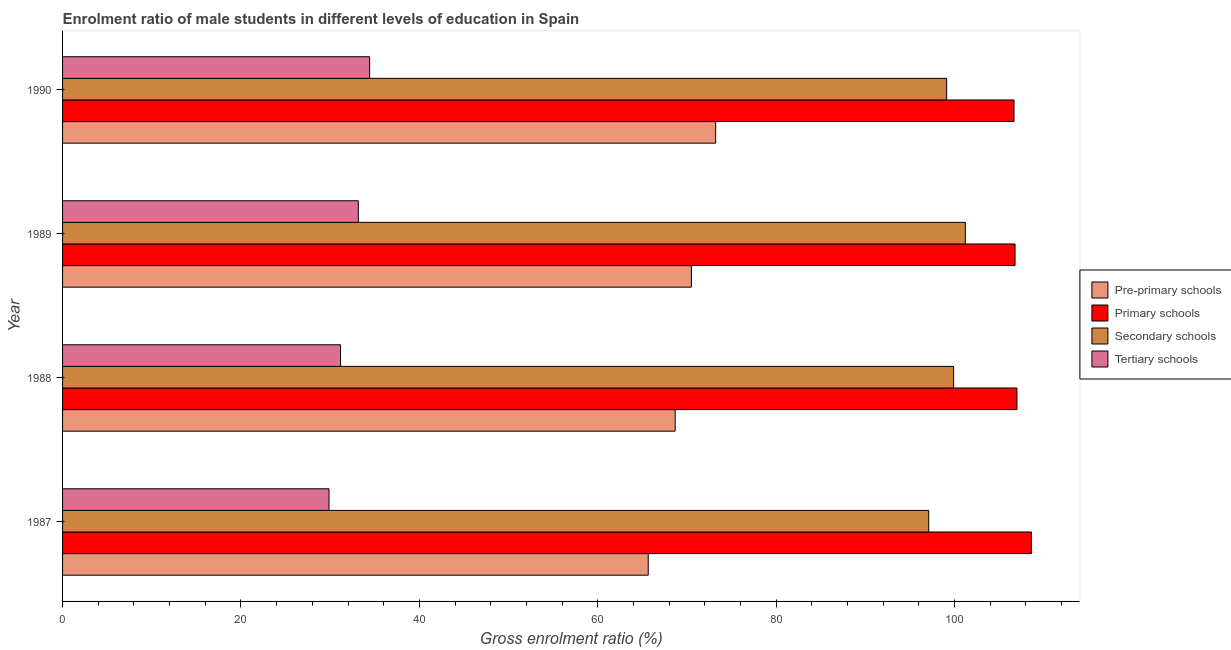How many groups of bars are there?
Keep it short and to the point. 4. Are the number of bars per tick equal to the number of legend labels?
Your answer should be compact. Yes. How many bars are there on the 3rd tick from the bottom?
Make the answer very short. 4. What is the gross enrolment ratio(female) in primary schools in 1989?
Provide a succinct answer. 106.78. Across all years, what is the maximum gross enrolment ratio(female) in pre-primary schools?
Offer a terse response. 73.22. Across all years, what is the minimum gross enrolment ratio(female) in secondary schools?
Provide a short and direct response. 97.1. In which year was the gross enrolment ratio(female) in secondary schools minimum?
Your answer should be compact. 1987. What is the total gross enrolment ratio(female) in primary schools in the graph?
Offer a very short reply. 429.06. What is the difference between the gross enrolment ratio(female) in pre-primary schools in 1987 and that in 1990?
Ensure brevity in your answer.  -7.56. What is the difference between the gross enrolment ratio(female) in pre-primary schools in 1988 and the gross enrolment ratio(female) in tertiary schools in 1987?
Make the answer very short. 38.81. What is the average gross enrolment ratio(female) in tertiary schools per year?
Provide a short and direct response. 32.15. In the year 1990, what is the difference between the gross enrolment ratio(female) in pre-primary schools and gross enrolment ratio(female) in secondary schools?
Give a very brief answer. -25.89. In how many years, is the gross enrolment ratio(female) in pre-primary schools greater than 12 %?
Your answer should be compact. 4. What is the ratio of the gross enrolment ratio(female) in primary schools in 1989 to that in 1990?
Make the answer very short. 1. Is the difference between the gross enrolment ratio(female) in primary schools in 1987 and 1988 greater than the difference between the gross enrolment ratio(female) in secondary schools in 1987 and 1988?
Ensure brevity in your answer.  Yes. What is the difference between the highest and the second highest gross enrolment ratio(female) in tertiary schools?
Provide a succinct answer. 1.27. What is the difference between the highest and the lowest gross enrolment ratio(female) in pre-primary schools?
Offer a terse response. 7.56. In how many years, is the gross enrolment ratio(female) in primary schools greater than the average gross enrolment ratio(female) in primary schools taken over all years?
Your answer should be compact. 1. Is the sum of the gross enrolment ratio(female) in pre-primary schools in 1988 and 1989 greater than the maximum gross enrolment ratio(female) in secondary schools across all years?
Ensure brevity in your answer.  Yes. Is it the case that in every year, the sum of the gross enrolment ratio(female) in pre-primary schools and gross enrolment ratio(female) in tertiary schools is greater than the sum of gross enrolment ratio(female) in secondary schools and gross enrolment ratio(female) in primary schools?
Provide a short and direct response. No. What does the 3rd bar from the top in 1988 represents?
Your answer should be compact. Primary schools. What does the 3rd bar from the bottom in 1988 represents?
Provide a short and direct response. Secondary schools. Is it the case that in every year, the sum of the gross enrolment ratio(female) in pre-primary schools and gross enrolment ratio(female) in primary schools is greater than the gross enrolment ratio(female) in secondary schools?
Give a very brief answer. Yes. How many years are there in the graph?
Your answer should be very brief. 4. Are the values on the major ticks of X-axis written in scientific E-notation?
Offer a terse response. No. Does the graph contain any zero values?
Keep it short and to the point. No. Does the graph contain grids?
Your answer should be very brief. No. Where does the legend appear in the graph?
Your answer should be very brief. Center right. What is the title of the graph?
Provide a succinct answer. Enrolment ratio of male students in different levels of education in Spain. What is the Gross enrolment ratio (%) in Pre-primary schools in 1987?
Provide a short and direct response. 65.66. What is the Gross enrolment ratio (%) of Primary schools in 1987?
Give a very brief answer. 108.62. What is the Gross enrolment ratio (%) in Secondary schools in 1987?
Your answer should be compact. 97.1. What is the Gross enrolment ratio (%) in Tertiary schools in 1987?
Ensure brevity in your answer.  29.87. What is the Gross enrolment ratio (%) of Pre-primary schools in 1988?
Offer a terse response. 68.68. What is the Gross enrolment ratio (%) in Primary schools in 1988?
Provide a succinct answer. 106.99. What is the Gross enrolment ratio (%) of Secondary schools in 1988?
Offer a terse response. 99.9. What is the Gross enrolment ratio (%) in Tertiary schools in 1988?
Your answer should be compact. 31.16. What is the Gross enrolment ratio (%) of Pre-primary schools in 1989?
Your answer should be compact. 70.5. What is the Gross enrolment ratio (%) in Primary schools in 1989?
Make the answer very short. 106.78. What is the Gross enrolment ratio (%) of Secondary schools in 1989?
Offer a very short reply. 101.21. What is the Gross enrolment ratio (%) of Tertiary schools in 1989?
Your answer should be very brief. 33.16. What is the Gross enrolment ratio (%) of Pre-primary schools in 1990?
Your answer should be compact. 73.22. What is the Gross enrolment ratio (%) of Primary schools in 1990?
Keep it short and to the point. 106.67. What is the Gross enrolment ratio (%) of Secondary schools in 1990?
Your response must be concise. 99.11. What is the Gross enrolment ratio (%) of Tertiary schools in 1990?
Make the answer very short. 34.42. Across all years, what is the maximum Gross enrolment ratio (%) of Pre-primary schools?
Provide a succinct answer. 73.22. Across all years, what is the maximum Gross enrolment ratio (%) of Primary schools?
Your response must be concise. 108.62. Across all years, what is the maximum Gross enrolment ratio (%) of Secondary schools?
Your answer should be very brief. 101.21. Across all years, what is the maximum Gross enrolment ratio (%) in Tertiary schools?
Ensure brevity in your answer.  34.42. Across all years, what is the minimum Gross enrolment ratio (%) in Pre-primary schools?
Your answer should be compact. 65.66. Across all years, what is the minimum Gross enrolment ratio (%) of Primary schools?
Ensure brevity in your answer.  106.67. Across all years, what is the minimum Gross enrolment ratio (%) of Secondary schools?
Provide a short and direct response. 97.1. Across all years, what is the minimum Gross enrolment ratio (%) in Tertiary schools?
Make the answer very short. 29.87. What is the total Gross enrolment ratio (%) of Pre-primary schools in the graph?
Make the answer very short. 278.06. What is the total Gross enrolment ratio (%) in Primary schools in the graph?
Provide a short and direct response. 429.06. What is the total Gross enrolment ratio (%) of Secondary schools in the graph?
Your answer should be compact. 397.32. What is the total Gross enrolment ratio (%) of Tertiary schools in the graph?
Your answer should be very brief. 128.62. What is the difference between the Gross enrolment ratio (%) of Pre-primary schools in 1987 and that in 1988?
Provide a short and direct response. -3.02. What is the difference between the Gross enrolment ratio (%) in Primary schools in 1987 and that in 1988?
Keep it short and to the point. 1.63. What is the difference between the Gross enrolment ratio (%) in Secondary schools in 1987 and that in 1988?
Ensure brevity in your answer.  -2.79. What is the difference between the Gross enrolment ratio (%) in Tertiary schools in 1987 and that in 1988?
Provide a succinct answer. -1.29. What is the difference between the Gross enrolment ratio (%) of Pre-primary schools in 1987 and that in 1989?
Provide a short and direct response. -4.84. What is the difference between the Gross enrolment ratio (%) in Primary schools in 1987 and that in 1989?
Keep it short and to the point. 1.84. What is the difference between the Gross enrolment ratio (%) of Secondary schools in 1987 and that in 1989?
Provide a short and direct response. -4.11. What is the difference between the Gross enrolment ratio (%) in Tertiary schools in 1987 and that in 1989?
Offer a very short reply. -3.28. What is the difference between the Gross enrolment ratio (%) of Pre-primary schools in 1987 and that in 1990?
Keep it short and to the point. -7.56. What is the difference between the Gross enrolment ratio (%) in Primary schools in 1987 and that in 1990?
Offer a terse response. 1.96. What is the difference between the Gross enrolment ratio (%) in Secondary schools in 1987 and that in 1990?
Provide a short and direct response. -2.01. What is the difference between the Gross enrolment ratio (%) in Tertiary schools in 1987 and that in 1990?
Offer a terse response. -4.55. What is the difference between the Gross enrolment ratio (%) of Pre-primary schools in 1988 and that in 1989?
Ensure brevity in your answer.  -1.82. What is the difference between the Gross enrolment ratio (%) of Primary schools in 1988 and that in 1989?
Keep it short and to the point. 0.21. What is the difference between the Gross enrolment ratio (%) of Secondary schools in 1988 and that in 1989?
Keep it short and to the point. -1.32. What is the difference between the Gross enrolment ratio (%) of Tertiary schools in 1988 and that in 1989?
Keep it short and to the point. -1.99. What is the difference between the Gross enrolment ratio (%) of Pre-primary schools in 1988 and that in 1990?
Make the answer very short. -4.54. What is the difference between the Gross enrolment ratio (%) of Primary schools in 1988 and that in 1990?
Your answer should be very brief. 0.33. What is the difference between the Gross enrolment ratio (%) in Secondary schools in 1988 and that in 1990?
Keep it short and to the point. 0.78. What is the difference between the Gross enrolment ratio (%) of Tertiary schools in 1988 and that in 1990?
Provide a succinct answer. -3.26. What is the difference between the Gross enrolment ratio (%) in Pre-primary schools in 1989 and that in 1990?
Give a very brief answer. -2.72. What is the difference between the Gross enrolment ratio (%) of Primary schools in 1989 and that in 1990?
Give a very brief answer. 0.12. What is the difference between the Gross enrolment ratio (%) of Secondary schools in 1989 and that in 1990?
Ensure brevity in your answer.  2.1. What is the difference between the Gross enrolment ratio (%) in Tertiary schools in 1989 and that in 1990?
Provide a succinct answer. -1.27. What is the difference between the Gross enrolment ratio (%) in Pre-primary schools in 1987 and the Gross enrolment ratio (%) in Primary schools in 1988?
Your response must be concise. -41.33. What is the difference between the Gross enrolment ratio (%) in Pre-primary schools in 1987 and the Gross enrolment ratio (%) in Secondary schools in 1988?
Offer a very short reply. -34.24. What is the difference between the Gross enrolment ratio (%) of Pre-primary schools in 1987 and the Gross enrolment ratio (%) of Tertiary schools in 1988?
Give a very brief answer. 34.49. What is the difference between the Gross enrolment ratio (%) in Primary schools in 1987 and the Gross enrolment ratio (%) in Secondary schools in 1988?
Keep it short and to the point. 8.73. What is the difference between the Gross enrolment ratio (%) of Primary schools in 1987 and the Gross enrolment ratio (%) of Tertiary schools in 1988?
Your answer should be compact. 77.46. What is the difference between the Gross enrolment ratio (%) in Secondary schools in 1987 and the Gross enrolment ratio (%) in Tertiary schools in 1988?
Your answer should be very brief. 65.94. What is the difference between the Gross enrolment ratio (%) of Pre-primary schools in 1987 and the Gross enrolment ratio (%) of Primary schools in 1989?
Make the answer very short. -41.12. What is the difference between the Gross enrolment ratio (%) of Pre-primary schools in 1987 and the Gross enrolment ratio (%) of Secondary schools in 1989?
Your response must be concise. -35.55. What is the difference between the Gross enrolment ratio (%) of Pre-primary schools in 1987 and the Gross enrolment ratio (%) of Tertiary schools in 1989?
Give a very brief answer. 32.5. What is the difference between the Gross enrolment ratio (%) of Primary schools in 1987 and the Gross enrolment ratio (%) of Secondary schools in 1989?
Make the answer very short. 7.41. What is the difference between the Gross enrolment ratio (%) in Primary schools in 1987 and the Gross enrolment ratio (%) in Tertiary schools in 1989?
Ensure brevity in your answer.  75.47. What is the difference between the Gross enrolment ratio (%) in Secondary schools in 1987 and the Gross enrolment ratio (%) in Tertiary schools in 1989?
Offer a very short reply. 63.95. What is the difference between the Gross enrolment ratio (%) in Pre-primary schools in 1987 and the Gross enrolment ratio (%) in Primary schools in 1990?
Your answer should be very brief. -41.01. What is the difference between the Gross enrolment ratio (%) in Pre-primary schools in 1987 and the Gross enrolment ratio (%) in Secondary schools in 1990?
Provide a short and direct response. -33.45. What is the difference between the Gross enrolment ratio (%) in Pre-primary schools in 1987 and the Gross enrolment ratio (%) in Tertiary schools in 1990?
Provide a succinct answer. 31.23. What is the difference between the Gross enrolment ratio (%) in Primary schools in 1987 and the Gross enrolment ratio (%) in Secondary schools in 1990?
Offer a very short reply. 9.51. What is the difference between the Gross enrolment ratio (%) in Primary schools in 1987 and the Gross enrolment ratio (%) in Tertiary schools in 1990?
Ensure brevity in your answer.  74.2. What is the difference between the Gross enrolment ratio (%) of Secondary schools in 1987 and the Gross enrolment ratio (%) of Tertiary schools in 1990?
Keep it short and to the point. 62.68. What is the difference between the Gross enrolment ratio (%) in Pre-primary schools in 1988 and the Gross enrolment ratio (%) in Primary schools in 1989?
Keep it short and to the point. -38.1. What is the difference between the Gross enrolment ratio (%) in Pre-primary schools in 1988 and the Gross enrolment ratio (%) in Secondary schools in 1989?
Provide a succinct answer. -32.53. What is the difference between the Gross enrolment ratio (%) in Pre-primary schools in 1988 and the Gross enrolment ratio (%) in Tertiary schools in 1989?
Your answer should be very brief. 35.53. What is the difference between the Gross enrolment ratio (%) in Primary schools in 1988 and the Gross enrolment ratio (%) in Secondary schools in 1989?
Your answer should be compact. 5.78. What is the difference between the Gross enrolment ratio (%) of Primary schools in 1988 and the Gross enrolment ratio (%) of Tertiary schools in 1989?
Offer a terse response. 73.84. What is the difference between the Gross enrolment ratio (%) in Secondary schools in 1988 and the Gross enrolment ratio (%) in Tertiary schools in 1989?
Provide a succinct answer. 66.74. What is the difference between the Gross enrolment ratio (%) in Pre-primary schools in 1988 and the Gross enrolment ratio (%) in Primary schools in 1990?
Your response must be concise. -37.98. What is the difference between the Gross enrolment ratio (%) in Pre-primary schools in 1988 and the Gross enrolment ratio (%) in Secondary schools in 1990?
Make the answer very short. -30.43. What is the difference between the Gross enrolment ratio (%) of Pre-primary schools in 1988 and the Gross enrolment ratio (%) of Tertiary schools in 1990?
Keep it short and to the point. 34.26. What is the difference between the Gross enrolment ratio (%) in Primary schools in 1988 and the Gross enrolment ratio (%) in Secondary schools in 1990?
Keep it short and to the point. 7.88. What is the difference between the Gross enrolment ratio (%) in Primary schools in 1988 and the Gross enrolment ratio (%) in Tertiary schools in 1990?
Your answer should be very brief. 72.57. What is the difference between the Gross enrolment ratio (%) of Secondary schools in 1988 and the Gross enrolment ratio (%) of Tertiary schools in 1990?
Offer a very short reply. 65.47. What is the difference between the Gross enrolment ratio (%) of Pre-primary schools in 1989 and the Gross enrolment ratio (%) of Primary schools in 1990?
Give a very brief answer. -36.17. What is the difference between the Gross enrolment ratio (%) of Pre-primary schools in 1989 and the Gross enrolment ratio (%) of Secondary schools in 1990?
Provide a short and direct response. -28.61. What is the difference between the Gross enrolment ratio (%) in Pre-primary schools in 1989 and the Gross enrolment ratio (%) in Tertiary schools in 1990?
Ensure brevity in your answer.  36.08. What is the difference between the Gross enrolment ratio (%) of Primary schools in 1989 and the Gross enrolment ratio (%) of Secondary schools in 1990?
Your answer should be very brief. 7.67. What is the difference between the Gross enrolment ratio (%) in Primary schools in 1989 and the Gross enrolment ratio (%) in Tertiary schools in 1990?
Your answer should be compact. 72.36. What is the difference between the Gross enrolment ratio (%) in Secondary schools in 1989 and the Gross enrolment ratio (%) in Tertiary schools in 1990?
Give a very brief answer. 66.79. What is the average Gross enrolment ratio (%) in Pre-primary schools per year?
Offer a very short reply. 69.51. What is the average Gross enrolment ratio (%) in Primary schools per year?
Offer a very short reply. 107.27. What is the average Gross enrolment ratio (%) in Secondary schools per year?
Make the answer very short. 99.33. What is the average Gross enrolment ratio (%) of Tertiary schools per year?
Give a very brief answer. 32.15. In the year 1987, what is the difference between the Gross enrolment ratio (%) in Pre-primary schools and Gross enrolment ratio (%) in Primary schools?
Offer a very short reply. -42.96. In the year 1987, what is the difference between the Gross enrolment ratio (%) in Pre-primary schools and Gross enrolment ratio (%) in Secondary schools?
Your response must be concise. -31.44. In the year 1987, what is the difference between the Gross enrolment ratio (%) in Pre-primary schools and Gross enrolment ratio (%) in Tertiary schools?
Keep it short and to the point. 35.79. In the year 1987, what is the difference between the Gross enrolment ratio (%) of Primary schools and Gross enrolment ratio (%) of Secondary schools?
Keep it short and to the point. 11.52. In the year 1987, what is the difference between the Gross enrolment ratio (%) of Primary schools and Gross enrolment ratio (%) of Tertiary schools?
Your answer should be very brief. 78.75. In the year 1987, what is the difference between the Gross enrolment ratio (%) in Secondary schools and Gross enrolment ratio (%) in Tertiary schools?
Provide a succinct answer. 67.23. In the year 1988, what is the difference between the Gross enrolment ratio (%) in Pre-primary schools and Gross enrolment ratio (%) in Primary schools?
Make the answer very short. -38.31. In the year 1988, what is the difference between the Gross enrolment ratio (%) of Pre-primary schools and Gross enrolment ratio (%) of Secondary schools?
Ensure brevity in your answer.  -31.21. In the year 1988, what is the difference between the Gross enrolment ratio (%) of Pre-primary schools and Gross enrolment ratio (%) of Tertiary schools?
Your answer should be compact. 37.52. In the year 1988, what is the difference between the Gross enrolment ratio (%) of Primary schools and Gross enrolment ratio (%) of Secondary schools?
Offer a terse response. 7.1. In the year 1988, what is the difference between the Gross enrolment ratio (%) in Primary schools and Gross enrolment ratio (%) in Tertiary schools?
Make the answer very short. 75.83. In the year 1988, what is the difference between the Gross enrolment ratio (%) of Secondary schools and Gross enrolment ratio (%) of Tertiary schools?
Your answer should be compact. 68.73. In the year 1989, what is the difference between the Gross enrolment ratio (%) of Pre-primary schools and Gross enrolment ratio (%) of Primary schools?
Provide a succinct answer. -36.28. In the year 1989, what is the difference between the Gross enrolment ratio (%) in Pre-primary schools and Gross enrolment ratio (%) in Secondary schools?
Provide a short and direct response. -30.71. In the year 1989, what is the difference between the Gross enrolment ratio (%) in Pre-primary schools and Gross enrolment ratio (%) in Tertiary schools?
Provide a short and direct response. 37.34. In the year 1989, what is the difference between the Gross enrolment ratio (%) of Primary schools and Gross enrolment ratio (%) of Secondary schools?
Provide a succinct answer. 5.57. In the year 1989, what is the difference between the Gross enrolment ratio (%) of Primary schools and Gross enrolment ratio (%) of Tertiary schools?
Your answer should be very brief. 73.63. In the year 1989, what is the difference between the Gross enrolment ratio (%) in Secondary schools and Gross enrolment ratio (%) in Tertiary schools?
Keep it short and to the point. 68.06. In the year 1990, what is the difference between the Gross enrolment ratio (%) in Pre-primary schools and Gross enrolment ratio (%) in Primary schools?
Provide a short and direct response. -33.45. In the year 1990, what is the difference between the Gross enrolment ratio (%) in Pre-primary schools and Gross enrolment ratio (%) in Secondary schools?
Offer a very short reply. -25.89. In the year 1990, what is the difference between the Gross enrolment ratio (%) in Pre-primary schools and Gross enrolment ratio (%) in Tertiary schools?
Make the answer very short. 38.79. In the year 1990, what is the difference between the Gross enrolment ratio (%) of Primary schools and Gross enrolment ratio (%) of Secondary schools?
Provide a short and direct response. 7.55. In the year 1990, what is the difference between the Gross enrolment ratio (%) in Primary schools and Gross enrolment ratio (%) in Tertiary schools?
Keep it short and to the point. 72.24. In the year 1990, what is the difference between the Gross enrolment ratio (%) in Secondary schools and Gross enrolment ratio (%) in Tertiary schools?
Your answer should be very brief. 64.69. What is the ratio of the Gross enrolment ratio (%) of Pre-primary schools in 1987 to that in 1988?
Offer a terse response. 0.96. What is the ratio of the Gross enrolment ratio (%) in Primary schools in 1987 to that in 1988?
Your answer should be very brief. 1.02. What is the ratio of the Gross enrolment ratio (%) of Secondary schools in 1987 to that in 1988?
Your response must be concise. 0.97. What is the ratio of the Gross enrolment ratio (%) of Tertiary schools in 1987 to that in 1988?
Provide a succinct answer. 0.96. What is the ratio of the Gross enrolment ratio (%) in Pre-primary schools in 1987 to that in 1989?
Offer a very short reply. 0.93. What is the ratio of the Gross enrolment ratio (%) in Primary schools in 1987 to that in 1989?
Your response must be concise. 1.02. What is the ratio of the Gross enrolment ratio (%) of Secondary schools in 1987 to that in 1989?
Your response must be concise. 0.96. What is the ratio of the Gross enrolment ratio (%) of Tertiary schools in 1987 to that in 1989?
Ensure brevity in your answer.  0.9. What is the ratio of the Gross enrolment ratio (%) in Pre-primary schools in 1987 to that in 1990?
Make the answer very short. 0.9. What is the ratio of the Gross enrolment ratio (%) of Primary schools in 1987 to that in 1990?
Ensure brevity in your answer.  1.02. What is the ratio of the Gross enrolment ratio (%) in Secondary schools in 1987 to that in 1990?
Ensure brevity in your answer.  0.98. What is the ratio of the Gross enrolment ratio (%) in Tertiary schools in 1987 to that in 1990?
Provide a succinct answer. 0.87. What is the ratio of the Gross enrolment ratio (%) in Pre-primary schools in 1988 to that in 1989?
Give a very brief answer. 0.97. What is the ratio of the Gross enrolment ratio (%) of Primary schools in 1988 to that in 1989?
Offer a very short reply. 1. What is the ratio of the Gross enrolment ratio (%) of Secondary schools in 1988 to that in 1989?
Offer a very short reply. 0.99. What is the ratio of the Gross enrolment ratio (%) of Tertiary schools in 1988 to that in 1989?
Your answer should be very brief. 0.94. What is the ratio of the Gross enrolment ratio (%) in Pre-primary schools in 1988 to that in 1990?
Provide a succinct answer. 0.94. What is the ratio of the Gross enrolment ratio (%) of Primary schools in 1988 to that in 1990?
Provide a short and direct response. 1. What is the ratio of the Gross enrolment ratio (%) in Secondary schools in 1988 to that in 1990?
Provide a short and direct response. 1.01. What is the ratio of the Gross enrolment ratio (%) in Tertiary schools in 1988 to that in 1990?
Provide a succinct answer. 0.91. What is the ratio of the Gross enrolment ratio (%) in Pre-primary schools in 1989 to that in 1990?
Provide a succinct answer. 0.96. What is the ratio of the Gross enrolment ratio (%) of Primary schools in 1989 to that in 1990?
Provide a short and direct response. 1. What is the ratio of the Gross enrolment ratio (%) in Secondary schools in 1989 to that in 1990?
Ensure brevity in your answer.  1.02. What is the ratio of the Gross enrolment ratio (%) of Tertiary schools in 1989 to that in 1990?
Offer a very short reply. 0.96. What is the difference between the highest and the second highest Gross enrolment ratio (%) in Pre-primary schools?
Your answer should be compact. 2.72. What is the difference between the highest and the second highest Gross enrolment ratio (%) of Primary schools?
Keep it short and to the point. 1.63. What is the difference between the highest and the second highest Gross enrolment ratio (%) of Secondary schools?
Your answer should be very brief. 1.32. What is the difference between the highest and the second highest Gross enrolment ratio (%) of Tertiary schools?
Your answer should be compact. 1.27. What is the difference between the highest and the lowest Gross enrolment ratio (%) of Pre-primary schools?
Make the answer very short. 7.56. What is the difference between the highest and the lowest Gross enrolment ratio (%) in Primary schools?
Provide a succinct answer. 1.96. What is the difference between the highest and the lowest Gross enrolment ratio (%) of Secondary schools?
Your response must be concise. 4.11. What is the difference between the highest and the lowest Gross enrolment ratio (%) in Tertiary schools?
Your response must be concise. 4.55. 